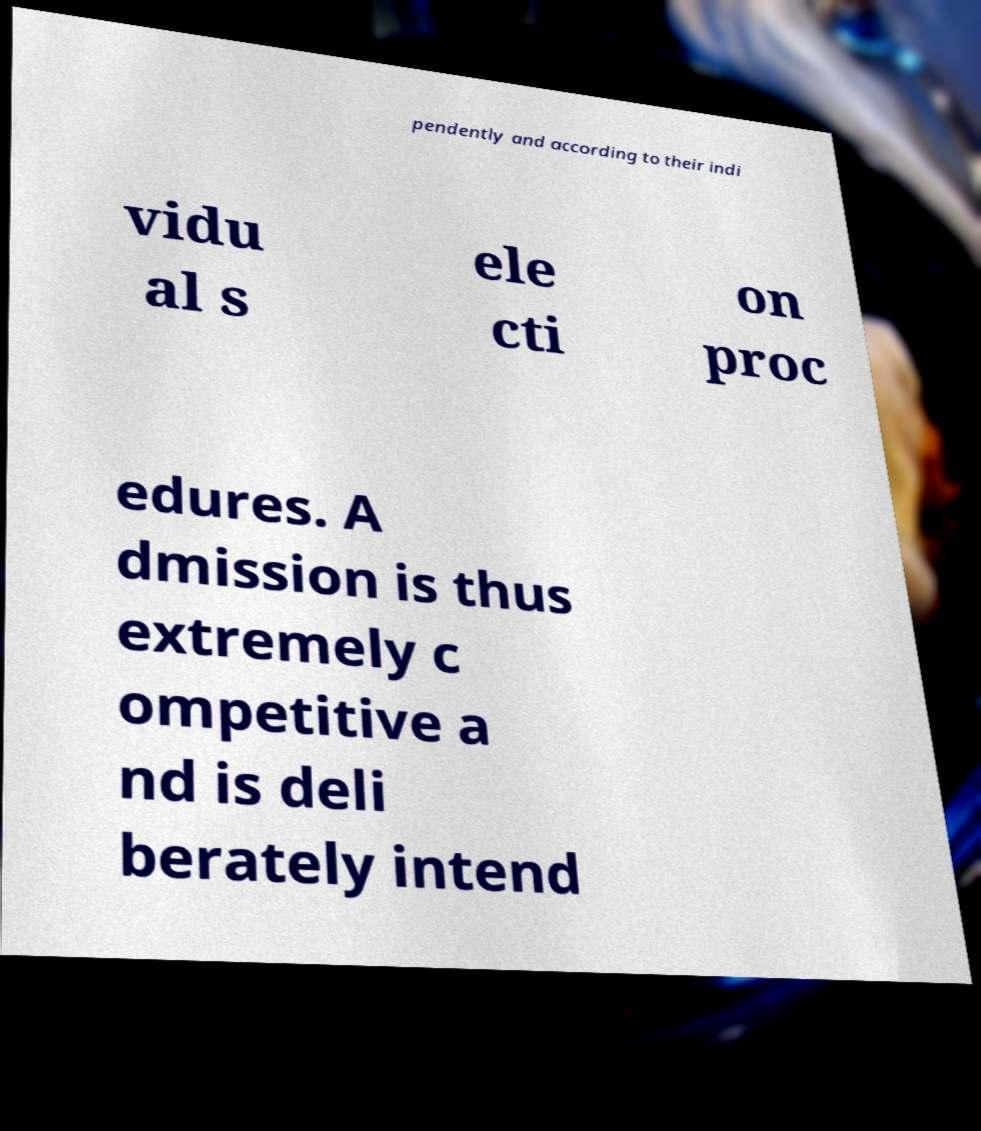Please identify and transcribe the text found in this image. pendently and according to their indi vidu al s ele cti on proc edures. A dmission is thus extremely c ompetitive a nd is deli berately intend 